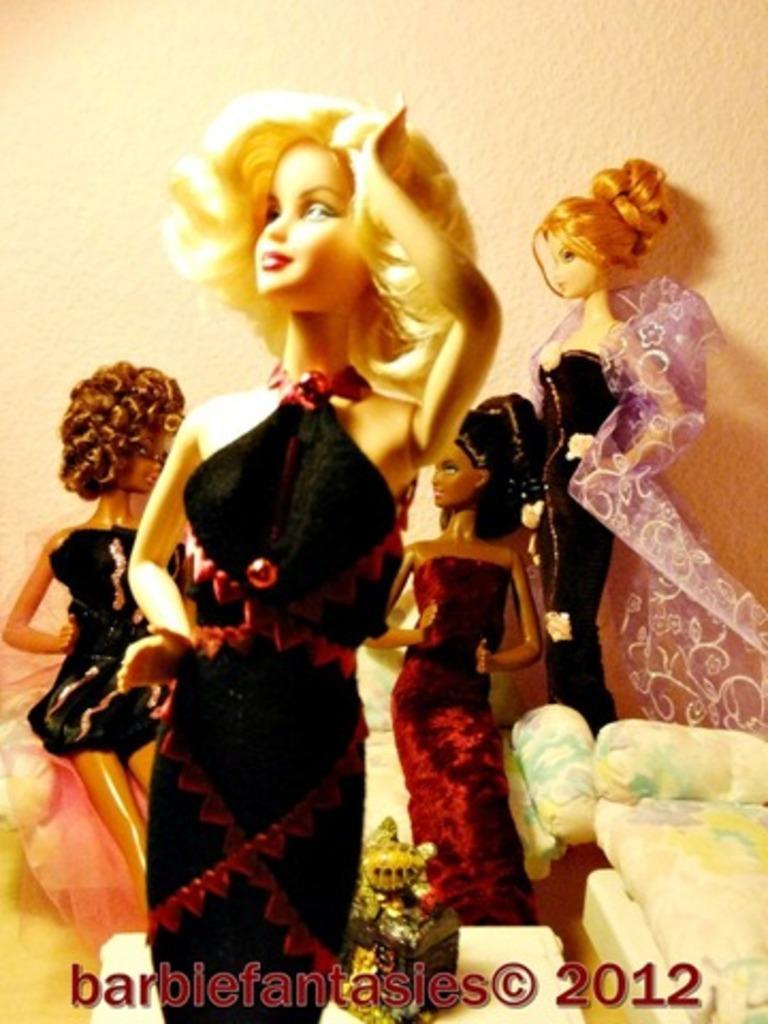In one or two sentences, can you explain what this image depicts? In this image I can see barbie dolls. Here I can see a watermark. In the background I can see a wall. 